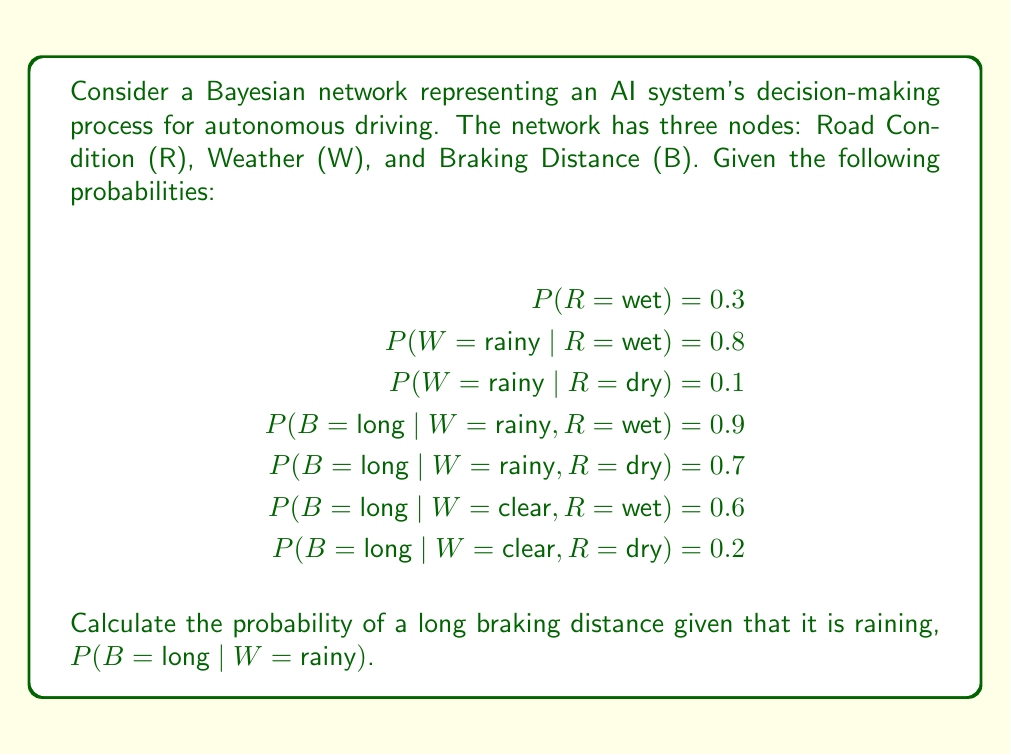Can you answer this question? To solve this problem, we'll use the law of total probability and Bayes' theorem. Let's break it down step by step:

1. We need to calculate P(B = long | W = rainy). We can use the law of total probability:

   $$P(B = long | W = rainy) = P(B = long | W = rainy, R = wet) \cdot P(R = wet | W = rainy) + P(B = long | W = rainy, R = dry) \cdot P(R = dry | W = rainy)$$

2. We're given P(B = long | W = rainy, R = wet) = 0.9 and P(B = long | W = rainy, R = dry) = 0.7, but we need to calculate P(R = wet | W = rainy) and P(R = dry | W = rainy).

3. Let's use Bayes' theorem to calculate P(R = wet | W = rainy):

   $$P(R = wet | W = rainy) = \frac{P(W = rainy | R = wet) \cdot P(R = wet)}{P(W = rainy)}$$

4. We know P(W = rainy | R = wet) = 0.8 and P(R = wet) = 0.3. We need to calculate P(W = rainy):

   $$P(W = rainy) = P(W = rainy | R = wet) \cdot P(R = wet) + P(W = rainy | R = dry) \cdot P(R = dry)$$
   $$P(W = rainy) = 0.8 \cdot 0.3 + 0.1 \cdot 0.7 = 0.31$$

5. Now we can calculate P(R = wet | W = rainy):

   $$P(R = wet | W = rainy) = \frac{0.8 \cdot 0.3}{0.31} \approx 0.7742$$

6. Consequently, P(R = dry | W = rainy) = 1 - 0.7742 = 0.2258

7. Now we can plug these values into our original equation:

   $$P(B = long | W = rainy) = 0.9 \cdot 0.7742 + 0.7 \cdot 0.2258$$
   $$P(B = long | W = rainy) = 0.6968 + 0.1581 = 0.8549$$

Therefore, the probability of a long braking distance given that it is raining is approximately 0.8549 or 85.49%.
Answer: P(B = long | W = rainy) ≈ 0.8549 or 85.49% 